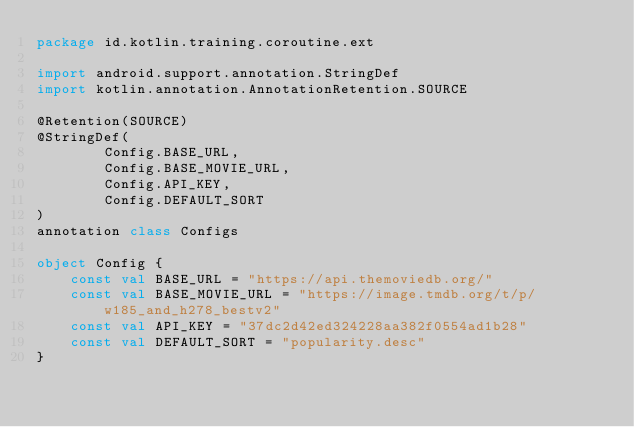Convert code to text. <code><loc_0><loc_0><loc_500><loc_500><_Kotlin_>package id.kotlin.training.coroutine.ext

import android.support.annotation.StringDef
import kotlin.annotation.AnnotationRetention.SOURCE

@Retention(SOURCE)
@StringDef(
        Config.BASE_URL,
        Config.BASE_MOVIE_URL,
        Config.API_KEY,
        Config.DEFAULT_SORT
)
annotation class Configs

object Config {
    const val BASE_URL = "https://api.themoviedb.org/"
    const val BASE_MOVIE_URL = "https://image.tmdb.org/t/p/w185_and_h278_bestv2"
    const val API_KEY = "37dc2d42ed324228aa382f0554ad1b28"
    const val DEFAULT_SORT = "popularity.desc"
}</code> 